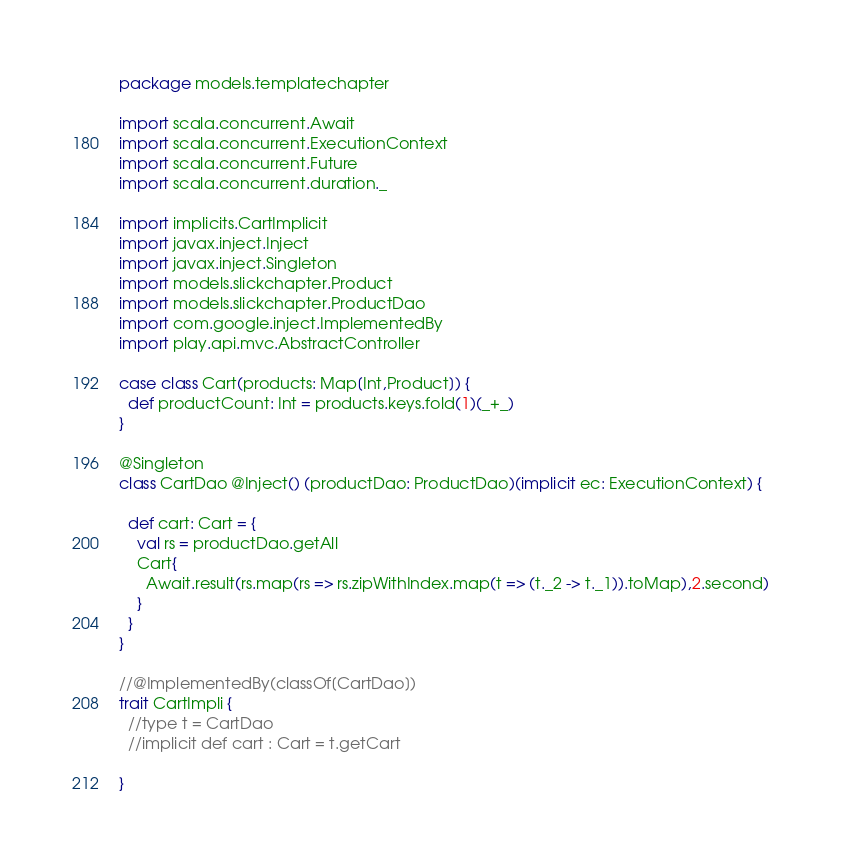Convert code to text. <code><loc_0><loc_0><loc_500><loc_500><_Scala_>package models.templatechapter

import scala.concurrent.Await
import scala.concurrent.ExecutionContext
import scala.concurrent.Future
import scala.concurrent.duration._

import implicits.CartImplicit
import javax.inject.Inject
import javax.inject.Singleton
import models.slickchapter.Product
import models.slickchapter.ProductDao
import com.google.inject.ImplementedBy
import play.api.mvc.AbstractController

case class Cart(products: Map[Int,Product]) {
  def productCount: Int = products.keys.fold(1)(_+_)
}

@Singleton
class CartDao @Inject() (productDao: ProductDao)(implicit ec: ExecutionContext) {
  
  def cart: Cart = { 
    val rs = productDao.getAll
    Cart{
      Await.result(rs.map(rs => rs.zipWithIndex.map(t => (t._2 -> t._1)).toMap),2.second)
    }
  }
}

//@ImplementedBy(classOf[CartDao])
trait CartImpli {
  //type t = CartDao
  //implicit def cart : Cart = t.getCart
  
}
</code> 